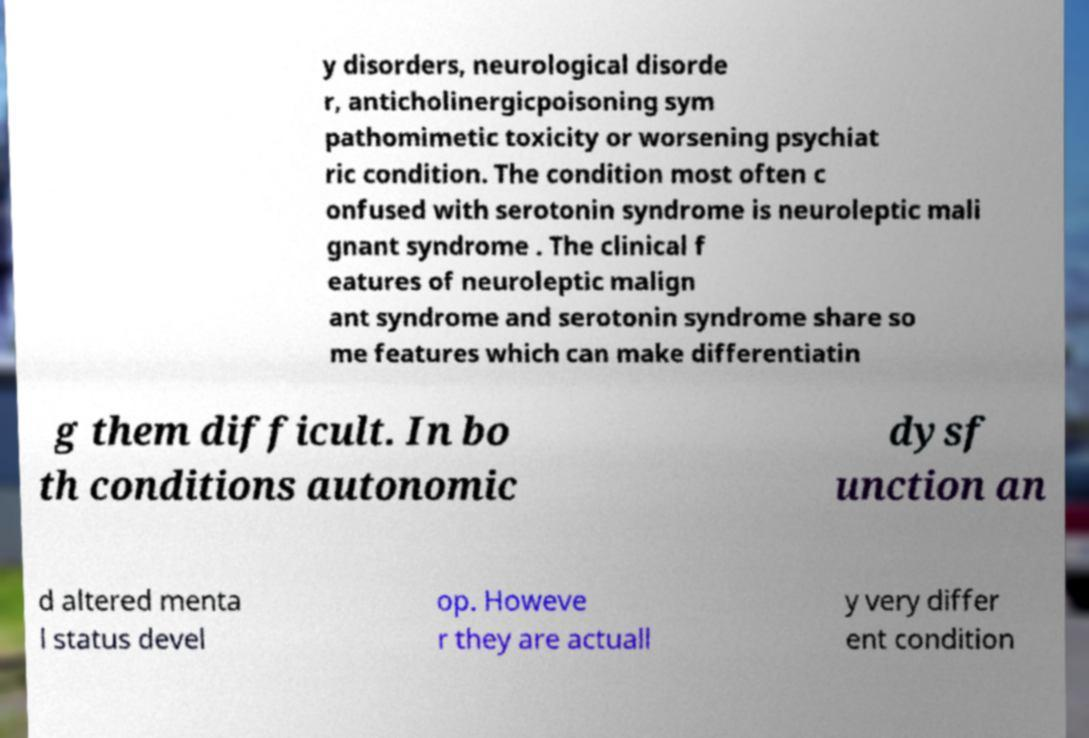Could you extract and type out the text from this image? y disorders, neurological disorde r, anticholinergicpoisoning sym pathomimetic toxicity or worsening psychiat ric condition. The condition most often c onfused with serotonin syndrome is neuroleptic mali gnant syndrome . The clinical f eatures of neuroleptic malign ant syndrome and serotonin syndrome share so me features which can make differentiatin g them difficult. In bo th conditions autonomic dysf unction an d altered menta l status devel op. Howeve r they are actuall y very differ ent condition 